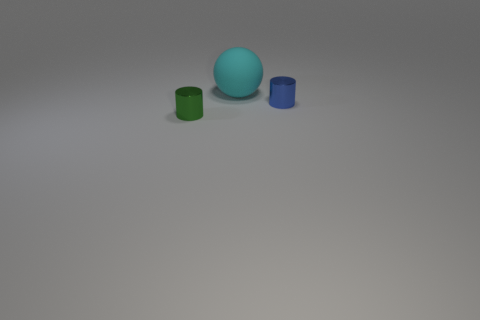Add 2 blue matte balls. How many objects exist? 5 Subtract all cylinders. How many objects are left? 1 Subtract 0 brown spheres. How many objects are left? 3 Subtract all tiny green matte cylinders. Subtract all tiny shiny things. How many objects are left? 1 Add 1 tiny green cylinders. How many tiny green cylinders are left? 2 Add 1 blue metallic cylinders. How many blue metallic cylinders exist? 2 